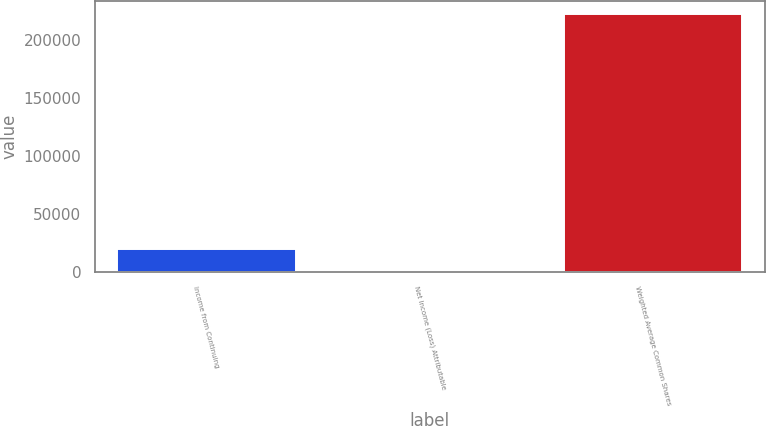Convert chart. <chart><loc_0><loc_0><loc_500><loc_500><bar_chart><fcel>Income from Continuing<fcel>Net Income (Loss) Attributable<fcel>Weighted Average Common Shares<nl><fcel>20199.4<fcel>0.29<fcel>222190<nl></chart> 